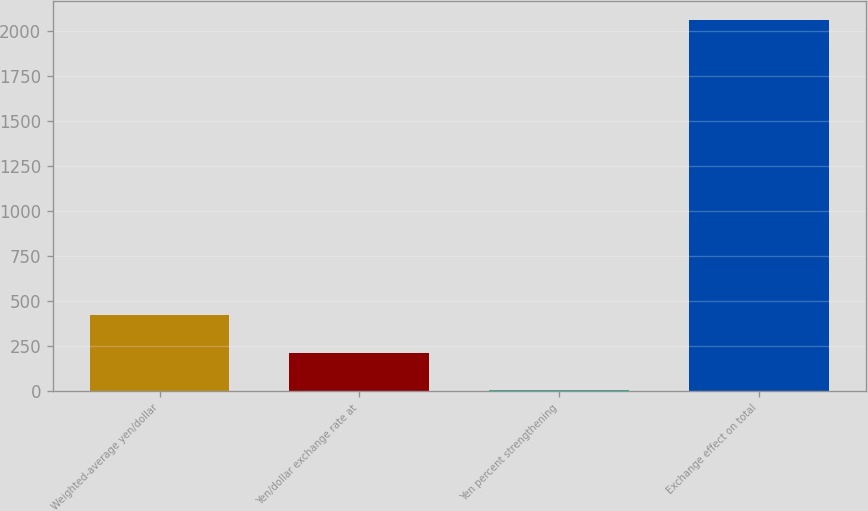Convert chart to OTSL. <chart><loc_0><loc_0><loc_500><loc_500><bar_chart><fcel>Weighted-average yen/dollar<fcel>Yen/dollar exchange rate at<fcel>Yen percent strengthening<fcel>Exchange effect on total<nl><fcel>423.84<fcel>214.07<fcel>4.3<fcel>2063<nl></chart> 